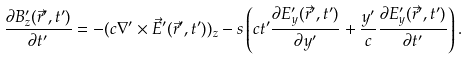<formula> <loc_0><loc_0><loc_500><loc_500>\frac { \partial B _ { z } ^ { \prime } ( \vec { r } ^ { \prime } , t ^ { \prime } ) } { \partial t ^ { \prime } } = - ( c \nabla ^ { \prime } \times \vec { E } ^ { \prime } ( \vec { r } ^ { \prime } , t ^ { \prime } ) ) _ { z } - s \left ( c t ^ { \prime } \frac { \partial E _ { y } ^ { \prime } ( \vec { r } ^ { \prime } , t ^ { \prime } ) } { \partial y ^ { \prime } } + \frac { y ^ { \prime } } { c } \frac { \partial E _ { y } ^ { \prime } ( \vec { r } ^ { \prime } , t ^ { \prime } ) } { \partial t ^ { \prime } } \right ) .</formula> 